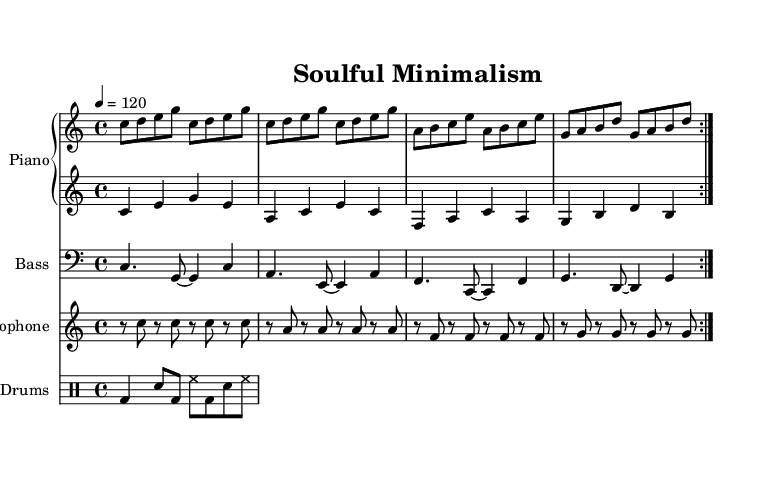What is the key signature of this music? The key signature is notated at the beginning of the sheet music, which indicates no sharps or flats, thus confirming that the piece is in C major.
Answer: C major What is the time signature of this music? The time signature is located beside the clef at the start of the score, shown as 4/4, meaning there are four beats in a measure and the quarter note gets one beat.
Answer: 4/4 What is the tempo of the piece? The tempo marking is indicated at the beginning of the score, and it specifies 120 beats per minute, which is a moderate pace for this piece.
Answer: 120 How many measures are in the piano right-hand part? Counting the repeated volta signs, we find that the right-hand part repeats twice with four measures each, leading to a total of eight measures.
Answer: 8 How does the bass rhythm pattern complement the overall groove? Analyzing the bass part, it features sustained notes with syncopation, interacting with the rest of the ensemble to create a steady, laid-back feel typical of soul-jazz fusion.
Answer: Syncopated What instrument plays a pattern of rests separated by the same pitch in the first section? The saxophone plays a pattern primarily composed of rests alternating with sustained notes, creating a flowing and minimalist effect, reminiscent of Terry Riley's style.
Answer: Saxophone What genre fusion is represented in this piece? The piece combines elements of soul music with jazz, exemplifying the essence of soul-jazz fusion and the minimalist influence of Terry Riley's "In C."
Answer: Soul-jazz fusion 